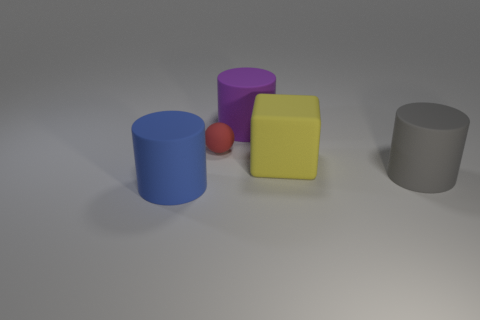Is there another large yellow ball made of the same material as the ball? no 